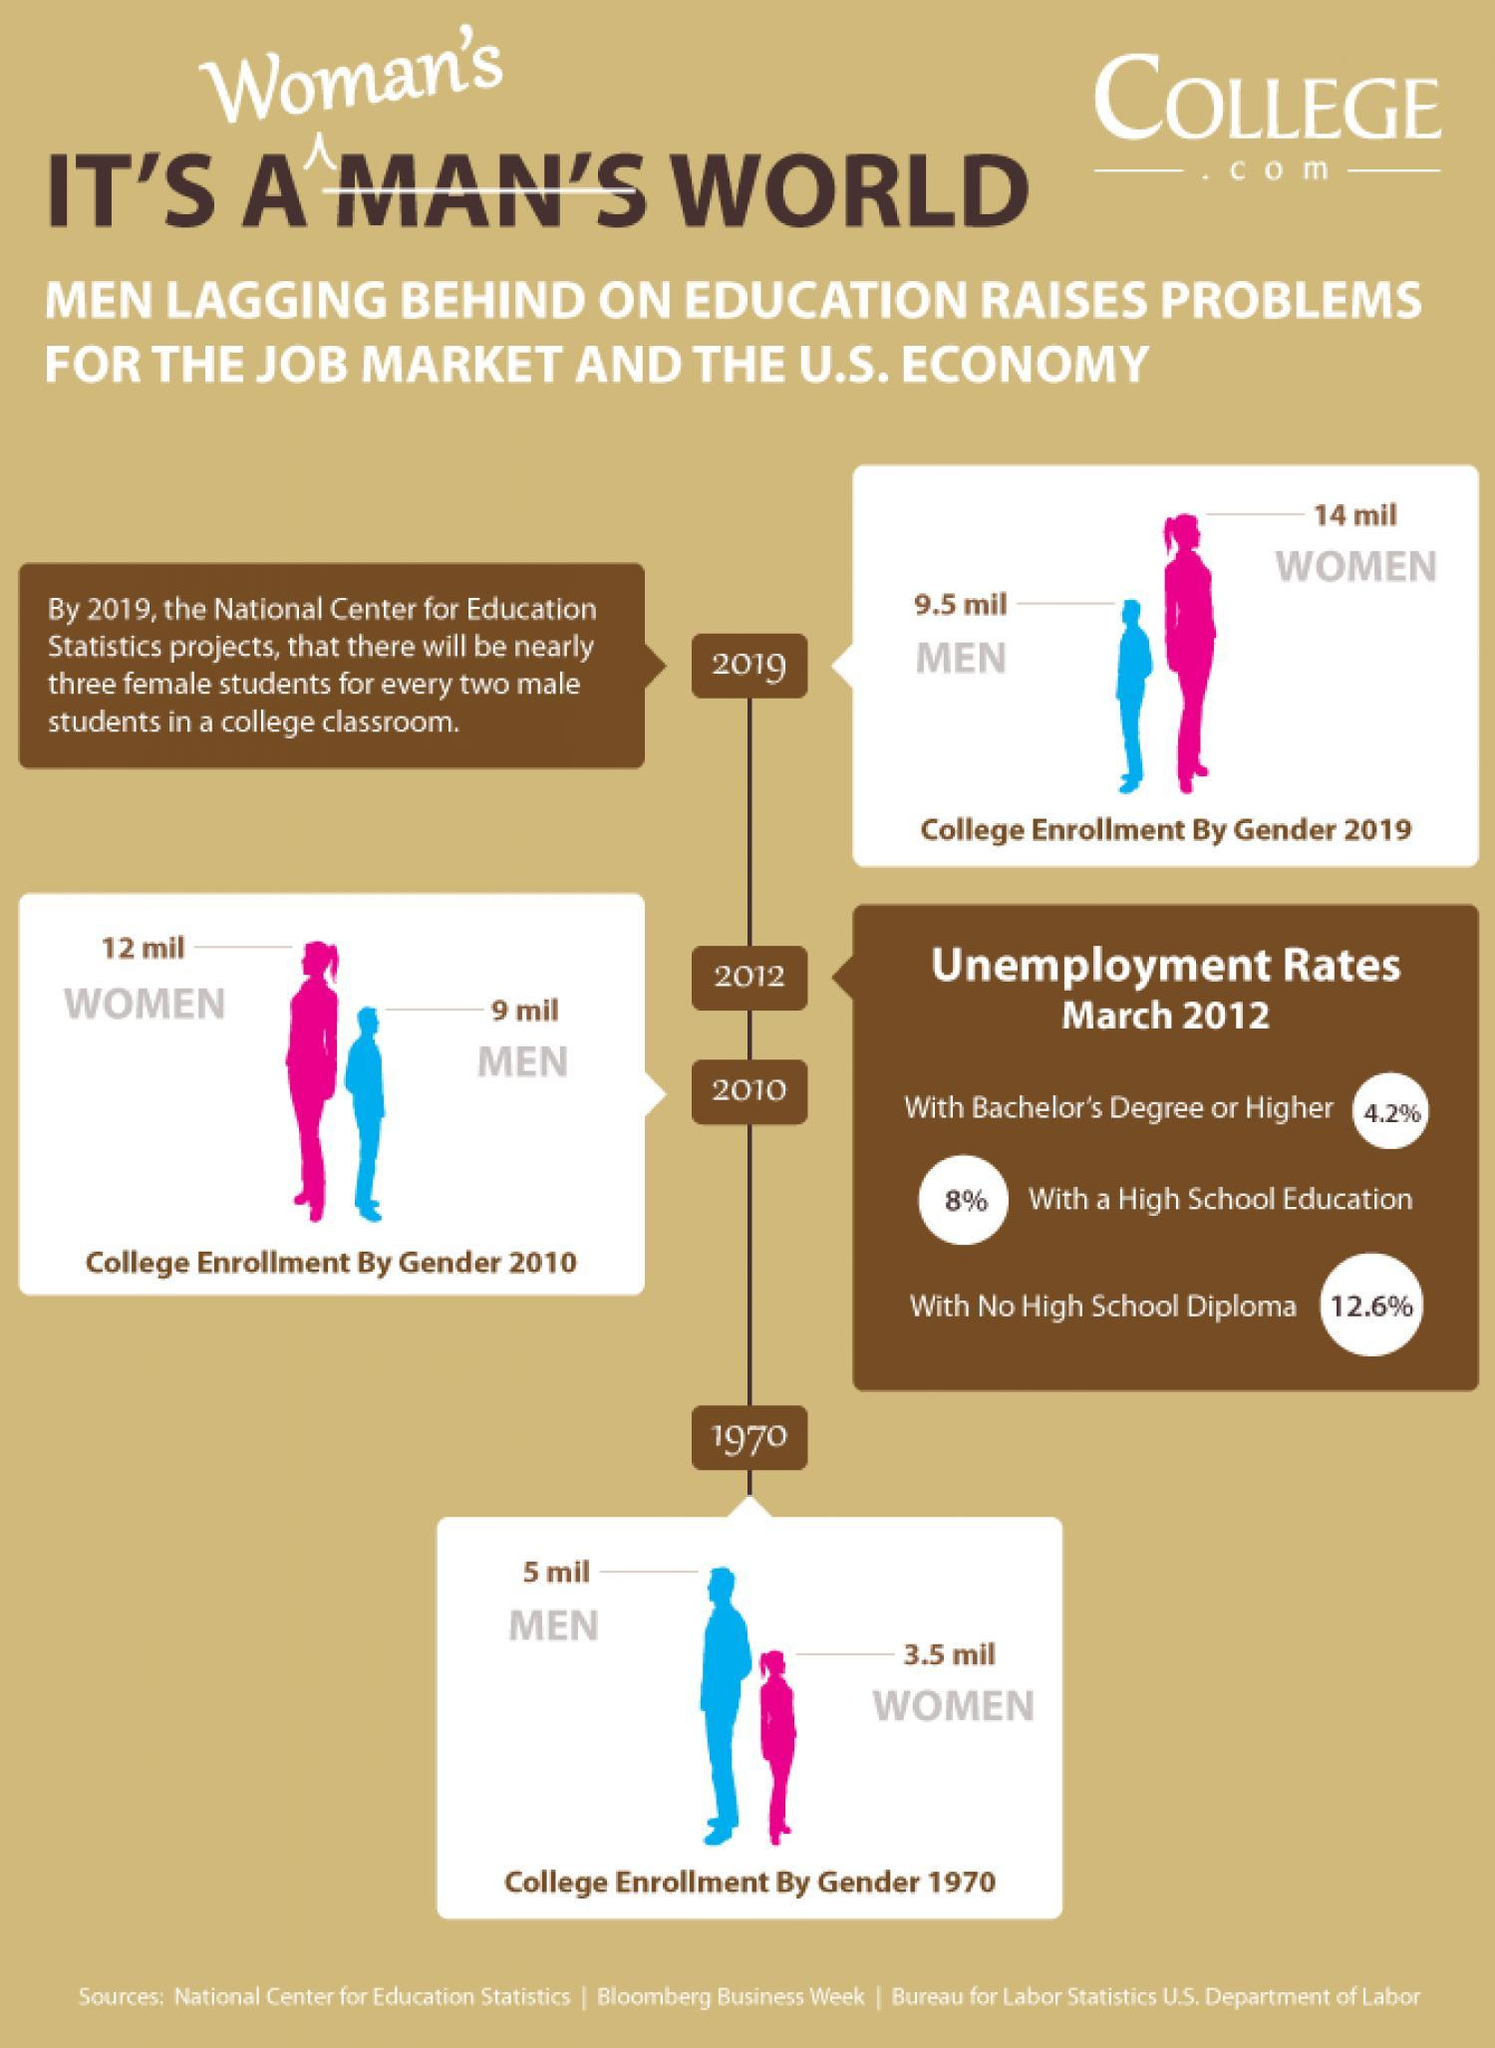By how many times is 3.5 million women enrolled in 1970 lesser than the 14 million women enrolled in 2019?
Answer the question with a short phrase. 4 times What is the increase in college enrolments of men from 2010 to 2019? 0.5 mil 